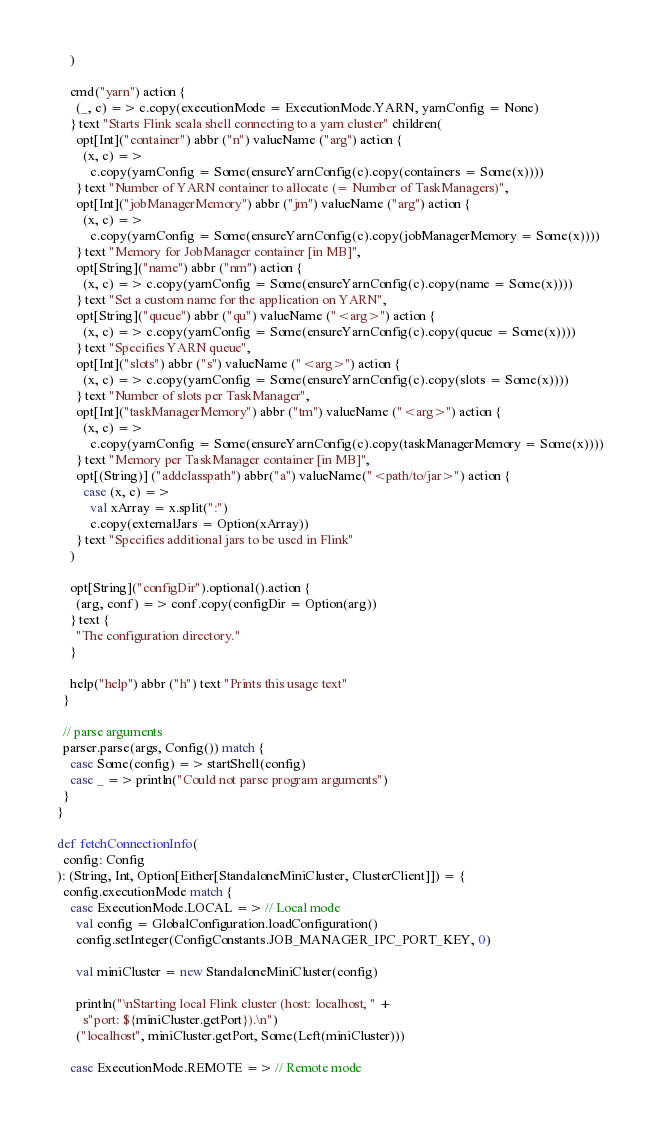Convert code to text. <code><loc_0><loc_0><loc_500><loc_500><_Scala_>      )

      cmd("yarn") action {
        (_, c) => c.copy(executionMode = ExecutionMode.YARN, yarnConfig = None)
      } text "Starts Flink scala shell connecting to a yarn cluster" children(
        opt[Int]("container") abbr ("n") valueName ("arg") action {
          (x, c) =>
            c.copy(yarnConfig = Some(ensureYarnConfig(c).copy(containers = Some(x))))
        } text "Number of YARN container to allocate (= Number of TaskManagers)",
        opt[Int]("jobManagerMemory") abbr ("jm") valueName ("arg") action {
          (x, c) =>
            c.copy(yarnConfig = Some(ensureYarnConfig(c).copy(jobManagerMemory = Some(x))))
        } text "Memory for JobManager container [in MB]",
        opt[String]("name") abbr ("nm") action {
          (x, c) => c.copy(yarnConfig = Some(ensureYarnConfig(c).copy(name = Some(x))))
        } text "Set a custom name for the application on YARN",
        opt[String]("queue") abbr ("qu") valueName ("<arg>") action {
          (x, c) => c.copy(yarnConfig = Some(ensureYarnConfig(c).copy(queue = Some(x))))
        } text "Specifies YARN queue",
        opt[Int]("slots") abbr ("s") valueName ("<arg>") action {
          (x, c) => c.copy(yarnConfig = Some(ensureYarnConfig(c).copy(slots = Some(x))))
        } text "Number of slots per TaskManager",
        opt[Int]("taskManagerMemory") abbr ("tm") valueName ("<arg>") action {
          (x, c) =>
            c.copy(yarnConfig = Some(ensureYarnConfig(c).copy(taskManagerMemory = Some(x))))
        } text "Memory per TaskManager container [in MB]",
        opt[(String)] ("addclasspath") abbr("a") valueName("<path/to/jar>") action {
          case (x, c) =>
            val xArray = x.split(":")
            c.copy(externalJars = Option(xArray))
        } text "Specifies additional jars to be used in Flink"
      )

      opt[String]("configDir").optional().action {
        (arg, conf) => conf.copy(configDir = Option(arg))
      } text {
        "The configuration directory."
      }

      help("help") abbr ("h") text "Prints this usage text"
    }

    // parse arguments
    parser.parse(args, Config()) match {
      case Some(config) => startShell(config)
      case _ => println("Could not parse program arguments")
    }
  }

  def fetchConnectionInfo(
    config: Config
  ): (String, Int, Option[Either[StandaloneMiniCluster, ClusterClient]]) = {
    config.executionMode match {
      case ExecutionMode.LOCAL => // Local mode
        val config = GlobalConfiguration.loadConfiguration()
        config.setInteger(ConfigConstants.JOB_MANAGER_IPC_PORT_KEY, 0)

        val miniCluster = new StandaloneMiniCluster(config)

        println("\nStarting local Flink cluster (host: localhost, " +
          s"port: ${miniCluster.getPort}).\n")
        ("localhost", miniCluster.getPort, Some(Left(miniCluster)))

      case ExecutionMode.REMOTE => // Remote mode</code> 